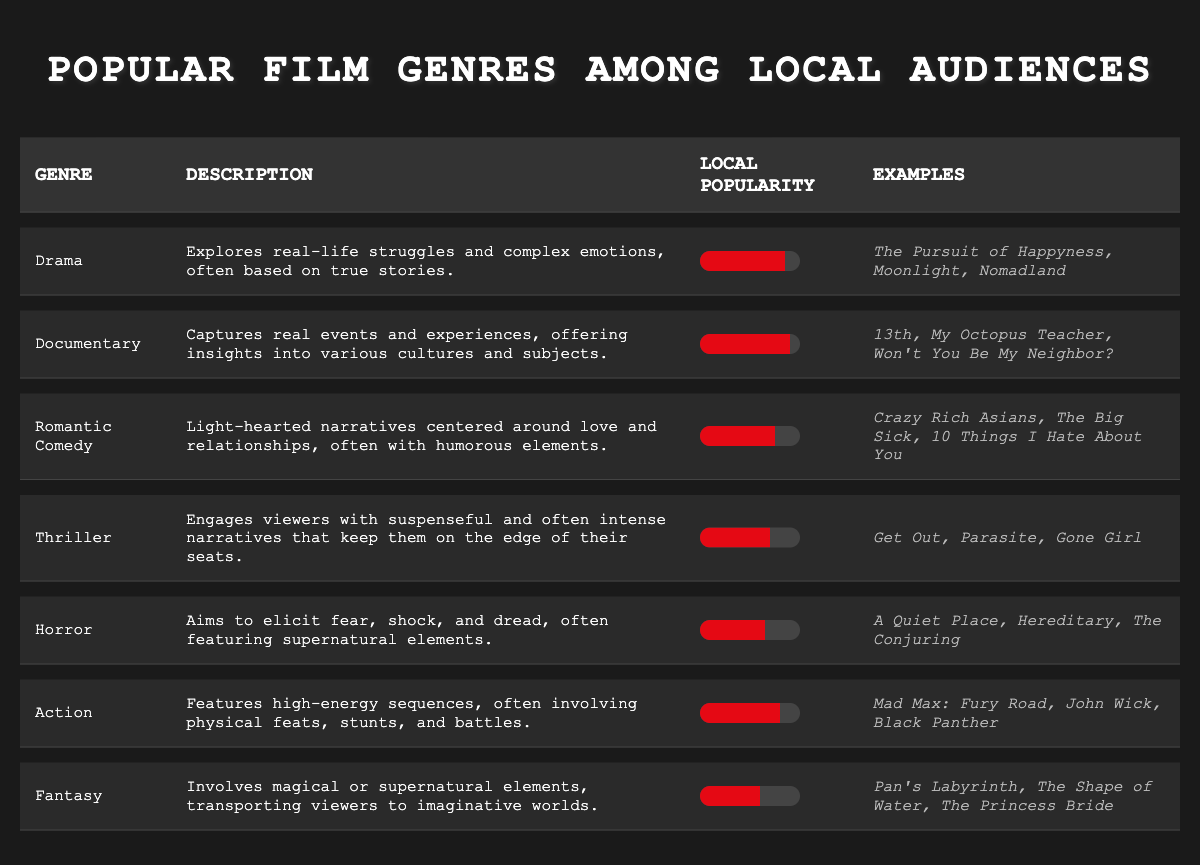What is the local popularity percentage of the Documentary genre? The table lists the local popularity of the Documentary genre as 90%. It's found in the "Local Popularity" column next to the genre name "Documentary."
Answer: 90% Which genre has the highest local popularity? The Documentary genre has the highest local popularity at 90%, as seen in the "Local Popularity" column.
Answer: Documentary How many genres have a local popularity of 70% or higher? The genres with 70% or higher popularity are Drama (85%), Documentary (90%), Action (80%), and Thriller (70%). There are four such genres.
Answer: 4 Is the Horror genre more popular than the Fantasy genre? Horror has a local popularity of 65%, while Fantasy has a local popularity of 60%. Since 65% is greater than 60%, Horror is indeed more popular.
Answer: Yes What is the average local popularity of the Drama and Action genres? The local popularity of Drama is 85% and Action is 80%. To find the average, add these two values (85% + 80% = 165%) and then divide by 2 (165% / 2 = 82.5%). Therefore, the average local popularity is 82.5%.
Answer: 82.5% 